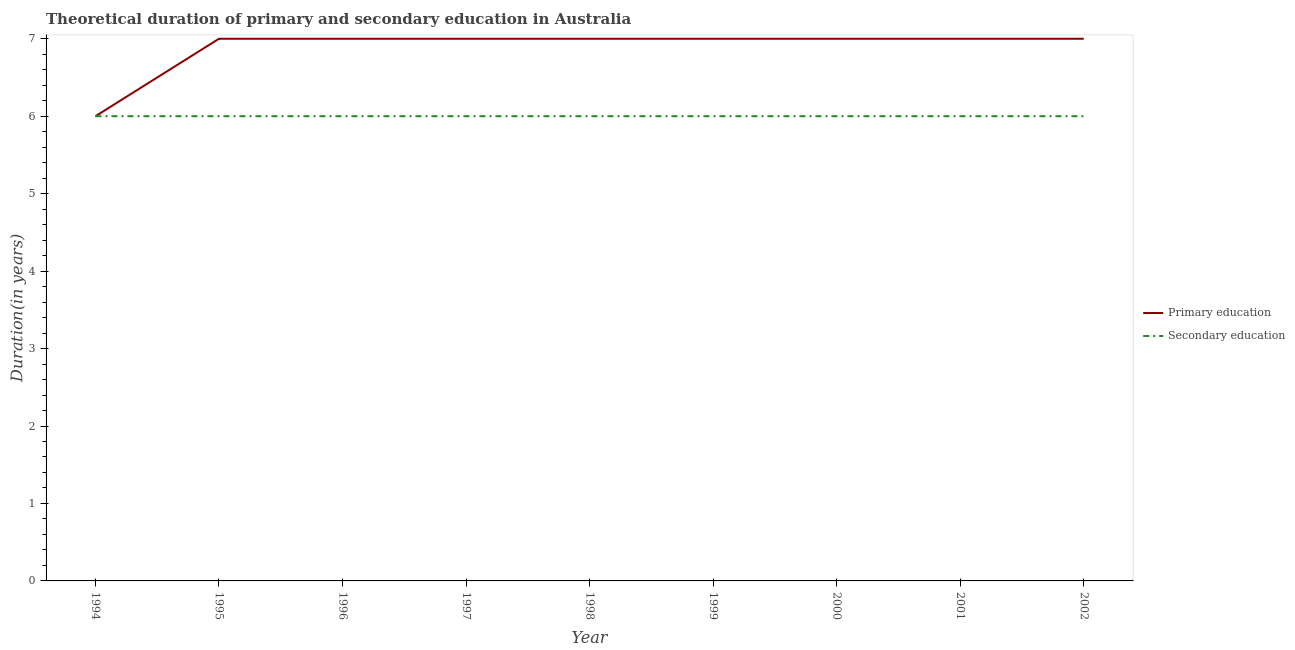How many different coloured lines are there?
Keep it short and to the point. 2. Does the line corresponding to duration of primary education intersect with the line corresponding to duration of secondary education?
Make the answer very short. Yes. Across all years, what is the maximum duration of primary education?
Your answer should be compact. 7. Across all years, what is the minimum duration of secondary education?
Provide a short and direct response. 6. What is the total duration of secondary education in the graph?
Make the answer very short. 54. What is the difference between the duration of primary education in 1995 and the duration of secondary education in 2000?
Make the answer very short. 1. What is the average duration of primary education per year?
Make the answer very short. 6.89. In the year 2000, what is the difference between the duration of primary education and duration of secondary education?
Ensure brevity in your answer.  1. What is the ratio of the duration of secondary education in 1998 to that in 2002?
Offer a terse response. 1. Is the duration of secondary education in 1997 less than that in 1998?
Give a very brief answer. No. Is the difference between the duration of primary education in 1999 and 2001 greater than the difference between the duration of secondary education in 1999 and 2001?
Your answer should be very brief. No. What is the difference between the highest and the lowest duration of secondary education?
Give a very brief answer. 0. In how many years, is the duration of secondary education greater than the average duration of secondary education taken over all years?
Keep it short and to the point. 0. Is the sum of the duration of secondary education in 2000 and 2002 greater than the maximum duration of primary education across all years?
Provide a succinct answer. Yes. Does the duration of primary education monotonically increase over the years?
Your answer should be compact. No. Is the duration of primary education strictly greater than the duration of secondary education over the years?
Keep it short and to the point. No. Is the duration of primary education strictly less than the duration of secondary education over the years?
Offer a terse response. No. What is the difference between two consecutive major ticks on the Y-axis?
Keep it short and to the point. 1. Are the values on the major ticks of Y-axis written in scientific E-notation?
Make the answer very short. No. Does the graph contain any zero values?
Give a very brief answer. No. How are the legend labels stacked?
Give a very brief answer. Vertical. What is the title of the graph?
Ensure brevity in your answer.  Theoretical duration of primary and secondary education in Australia. Does "Underweight" appear as one of the legend labels in the graph?
Offer a very short reply. No. What is the label or title of the Y-axis?
Offer a terse response. Duration(in years). What is the Duration(in years) of Secondary education in 1995?
Make the answer very short. 6. What is the Duration(in years) in Primary education in 1996?
Your answer should be very brief. 7. What is the Duration(in years) in Secondary education in 1996?
Your answer should be compact. 6. What is the Duration(in years) of Primary education in 1997?
Your answer should be compact. 7. What is the Duration(in years) in Secondary education in 1998?
Ensure brevity in your answer.  6. What is the Duration(in years) of Primary education in 2000?
Your answer should be very brief. 7. What is the Duration(in years) in Secondary education in 2000?
Make the answer very short. 6. What is the Duration(in years) in Primary education in 2001?
Your answer should be compact. 7. What is the Duration(in years) in Secondary education in 2001?
Ensure brevity in your answer.  6. What is the Duration(in years) of Primary education in 2002?
Your answer should be very brief. 7. Across all years, what is the maximum Duration(in years) in Secondary education?
Make the answer very short. 6. Across all years, what is the minimum Duration(in years) of Primary education?
Give a very brief answer. 6. What is the total Duration(in years) in Primary education in the graph?
Make the answer very short. 62. What is the total Duration(in years) in Secondary education in the graph?
Your answer should be compact. 54. What is the difference between the Duration(in years) in Primary education in 1994 and that in 1995?
Keep it short and to the point. -1. What is the difference between the Duration(in years) in Secondary education in 1994 and that in 1996?
Your answer should be very brief. 0. What is the difference between the Duration(in years) of Primary education in 1994 and that in 1997?
Provide a short and direct response. -1. What is the difference between the Duration(in years) in Secondary education in 1994 and that in 1997?
Ensure brevity in your answer.  0. What is the difference between the Duration(in years) of Primary education in 1994 and that in 1998?
Offer a terse response. -1. What is the difference between the Duration(in years) of Primary education in 1994 and that in 1999?
Give a very brief answer. -1. What is the difference between the Duration(in years) in Primary education in 1994 and that in 2000?
Provide a succinct answer. -1. What is the difference between the Duration(in years) in Primary education in 1994 and that in 2001?
Offer a terse response. -1. What is the difference between the Duration(in years) in Primary education in 1994 and that in 2002?
Provide a short and direct response. -1. What is the difference between the Duration(in years) in Secondary education in 1994 and that in 2002?
Ensure brevity in your answer.  0. What is the difference between the Duration(in years) of Primary education in 1995 and that in 1996?
Keep it short and to the point. 0. What is the difference between the Duration(in years) of Secondary education in 1995 and that in 1998?
Provide a short and direct response. 0. What is the difference between the Duration(in years) in Secondary education in 1995 and that in 1999?
Your answer should be very brief. 0. What is the difference between the Duration(in years) of Primary education in 1995 and that in 2001?
Give a very brief answer. 0. What is the difference between the Duration(in years) in Secondary education in 1995 and that in 2001?
Offer a very short reply. 0. What is the difference between the Duration(in years) of Primary education in 1995 and that in 2002?
Provide a succinct answer. 0. What is the difference between the Duration(in years) in Secondary education in 1995 and that in 2002?
Your answer should be very brief. 0. What is the difference between the Duration(in years) of Primary education in 1996 and that in 1997?
Provide a succinct answer. 0. What is the difference between the Duration(in years) of Secondary education in 1996 and that in 1997?
Your answer should be compact. 0. What is the difference between the Duration(in years) in Primary education in 1996 and that in 1999?
Ensure brevity in your answer.  0. What is the difference between the Duration(in years) in Secondary education in 1996 and that in 1999?
Your answer should be compact. 0. What is the difference between the Duration(in years) of Primary education in 1996 and that in 2000?
Keep it short and to the point. 0. What is the difference between the Duration(in years) in Secondary education in 1996 and that in 2000?
Ensure brevity in your answer.  0. What is the difference between the Duration(in years) in Primary education in 1996 and that in 2001?
Your answer should be very brief. 0. What is the difference between the Duration(in years) of Primary education in 1996 and that in 2002?
Your answer should be compact. 0. What is the difference between the Duration(in years) of Primary education in 1997 and that in 2000?
Your answer should be compact. 0. What is the difference between the Duration(in years) in Secondary education in 1997 and that in 2000?
Provide a short and direct response. 0. What is the difference between the Duration(in years) in Primary education in 1997 and that in 2001?
Offer a very short reply. 0. What is the difference between the Duration(in years) in Secondary education in 1997 and that in 2002?
Offer a very short reply. 0. What is the difference between the Duration(in years) of Secondary education in 1998 and that in 2000?
Your response must be concise. 0. What is the difference between the Duration(in years) in Primary education in 1998 and that in 2002?
Your answer should be very brief. 0. What is the difference between the Duration(in years) of Secondary education in 1998 and that in 2002?
Your answer should be compact. 0. What is the difference between the Duration(in years) in Primary education in 1999 and that in 2001?
Your answer should be compact. 0. What is the difference between the Duration(in years) of Secondary education in 1999 and that in 2002?
Provide a succinct answer. 0. What is the difference between the Duration(in years) in Primary education in 2000 and that in 2002?
Your answer should be compact. 0. What is the difference between the Duration(in years) of Secondary education in 2000 and that in 2002?
Provide a succinct answer. 0. What is the difference between the Duration(in years) of Secondary education in 2001 and that in 2002?
Your answer should be compact. 0. What is the difference between the Duration(in years) in Primary education in 1994 and the Duration(in years) in Secondary education in 1996?
Make the answer very short. 0. What is the difference between the Duration(in years) of Primary education in 1994 and the Duration(in years) of Secondary education in 1998?
Offer a terse response. 0. What is the difference between the Duration(in years) in Primary education in 1995 and the Duration(in years) in Secondary education in 1997?
Make the answer very short. 1. What is the difference between the Duration(in years) in Primary education in 1995 and the Duration(in years) in Secondary education in 2000?
Keep it short and to the point. 1. What is the difference between the Duration(in years) of Primary education in 1996 and the Duration(in years) of Secondary education in 1997?
Provide a short and direct response. 1. What is the difference between the Duration(in years) of Primary education in 1996 and the Duration(in years) of Secondary education in 1998?
Your answer should be compact. 1. What is the difference between the Duration(in years) of Primary education in 1997 and the Duration(in years) of Secondary education in 1998?
Your answer should be very brief. 1. What is the difference between the Duration(in years) in Primary education in 1997 and the Duration(in years) in Secondary education in 1999?
Your response must be concise. 1. What is the difference between the Duration(in years) in Primary education in 1997 and the Duration(in years) in Secondary education in 2000?
Give a very brief answer. 1. What is the difference between the Duration(in years) in Primary education in 1997 and the Duration(in years) in Secondary education in 2001?
Keep it short and to the point. 1. What is the difference between the Duration(in years) in Primary education in 1997 and the Duration(in years) in Secondary education in 2002?
Provide a succinct answer. 1. What is the difference between the Duration(in years) in Primary education in 1998 and the Duration(in years) in Secondary education in 1999?
Keep it short and to the point. 1. What is the difference between the Duration(in years) in Primary education in 1998 and the Duration(in years) in Secondary education in 2001?
Offer a very short reply. 1. What is the difference between the Duration(in years) of Primary education in 1999 and the Duration(in years) of Secondary education in 2000?
Make the answer very short. 1. What is the difference between the Duration(in years) in Primary education in 2000 and the Duration(in years) in Secondary education in 2001?
Your answer should be very brief. 1. What is the difference between the Duration(in years) of Primary education in 2001 and the Duration(in years) of Secondary education in 2002?
Your answer should be compact. 1. What is the average Duration(in years) in Primary education per year?
Give a very brief answer. 6.89. What is the average Duration(in years) in Secondary education per year?
Your answer should be compact. 6. In the year 1994, what is the difference between the Duration(in years) of Primary education and Duration(in years) of Secondary education?
Your answer should be compact. 0. In the year 1995, what is the difference between the Duration(in years) of Primary education and Duration(in years) of Secondary education?
Offer a very short reply. 1. In the year 1996, what is the difference between the Duration(in years) of Primary education and Duration(in years) of Secondary education?
Ensure brevity in your answer.  1. In the year 1997, what is the difference between the Duration(in years) of Primary education and Duration(in years) of Secondary education?
Ensure brevity in your answer.  1. In the year 2001, what is the difference between the Duration(in years) of Primary education and Duration(in years) of Secondary education?
Your response must be concise. 1. What is the ratio of the Duration(in years) of Primary education in 1994 to that in 1996?
Give a very brief answer. 0.86. What is the ratio of the Duration(in years) of Secondary education in 1994 to that in 1996?
Ensure brevity in your answer.  1. What is the ratio of the Duration(in years) of Primary education in 1994 to that in 1997?
Offer a very short reply. 0.86. What is the ratio of the Duration(in years) in Secondary education in 1994 to that in 1997?
Your answer should be compact. 1. What is the ratio of the Duration(in years) in Secondary education in 1994 to that in 1998?
Your answer should be very brief. 1. What is the ratio of the Duration(in years) of Secondary education in 1994 to that in 2000?
Provide a short and direct response. 1. What is the ratio of the Duration(in years) in Primary education in 1995 to that in 1996?
Give a very brief answer. 1. What is the ratio of the Duration(in years) in Secondary education in 1995 to that in 1996?
Keep it short and to the point. 1. What is the ratio of the Duration(in years) in Secondary education in 1995 to that in 1997?
Offer a very short reply. 1. What is the ratio of the Duration(in years) in Primary education in 1995 to that in 1998?
Offer a terse response. 1. What is the ratio of the Duration(in years) of Secondary education in 1995 to that in 1999?
Provide a succinct answer. 1. What is the ratio of the Duration(in years) of Primary education in 1995 to that in 2000?
Your response must be concise. 1. What is the ratio of the Duration(in years) of Secondary education in 1995 to that in 2000?
Offer a very short reply. 1. What is the ratio of the Duration(in years) of Secondary education in 1995 to that in 2001?
Make the answer very short. 1. What is the ratio of the Duration(in years) in Secondary education in 1995 to that in 2002?
Offer a very short reply. 1. What is the ratio of the Duration(in years) of Primary education in 1996 to that in 1998?
Provide a short and direct response. 1. What is the ratio of the Duration(in years) of Primary education in 1996 to that in 1999?
Give a very brief answer. 1. What is the ratio of the Duration(in years) in Secondary education in 1996 to that in 2002?
Provide a succinct answer. 1. What is the ratio of the Duration(in years) of Primary education in 1997 to that in 1998?
Ensure brevity in your answer.  1. What is the ratio of the Duration(in years) in Secondary education in 1997 to that in 1998?
Offer a very short reply. 1. What is the ratio of the Duration(in years) in Primary education in 1997 to that in 1999?
Ensure brevity in your answer.  1. What is the ratio of the Duration(in years) of Secondary education in 1997 to that in 1999?
Your answer should be very brief. 1. What is the ratio of the Duration(in years) in Primary education in 1997 to that in 2000?
Offer a terse response. 1. What is the ratio of the Duration(in years) in Secondary education in 1997 to that in 2000?
Your answer should be very brief. 1. What is the ratio of the Duration(in years) in Primary education in 1997 to that in 2001?
Provide a succinct answer. 1. What is the ratio of the Duration(in years) of Primary education in 1998 to that in 1999?
Your answer should be very brief. 1. What is the ratio of the Duration(in years) in Secondary education in 1998 to that in 1999?
Make the answer very short. 1. What is the ratio of the Duration(in years) of Primary education in 1998 to that in 2000?
Your response must be concise. 1. What is the ratio of the Duration(in years) of Secondary education in 1998 to that in 2000?
Provide a succinct answer. 1. What is the ratio of the Duration(in years) of Secondary education in 1998 to that in 2001?
Keep it short and to the point. 1. What is the ratio of the Duration(in years) in Primary education in 1998 to that in 2002?
Your response must be concise. 1. What is the ratio of the Duration(in years) of Primary education in 1999 to that in 2000?
Provide a succinct answer. 1. What is the ratio of the Duration(in years) of Secondary education in 1999 to that in 2000?
Your answer should be compact. 1. What is the ratio of the Duration(in years) in Secondary education in 1999 to that in 2001?
Your answer should be very brief. 1. What is the ratio of the Duration(in years) in Secondary education in 1999 to that in 2002?
Your answer should be compact. 1. What is the ratio of the Duration(in years) of Primary education in 2000 to that in 2001?
Ensure brevity in your answer.  1. What is the ratio of the Duration(in years) of Primary education in 2000 to that in 2002?
Offer a terse response. 1. What is the ratio of the Duration(in years) in Secondary education in 2001 to that in 2002?
Ensure brevity in your answer.  1. What is the difference between the highest and the second highest Duration(in years) in Secondary education?
Give a very brief answer. 0. What is the difference between the highest and the lowest Duration(in years) in Primary education?
Make the answer very short. 1. 